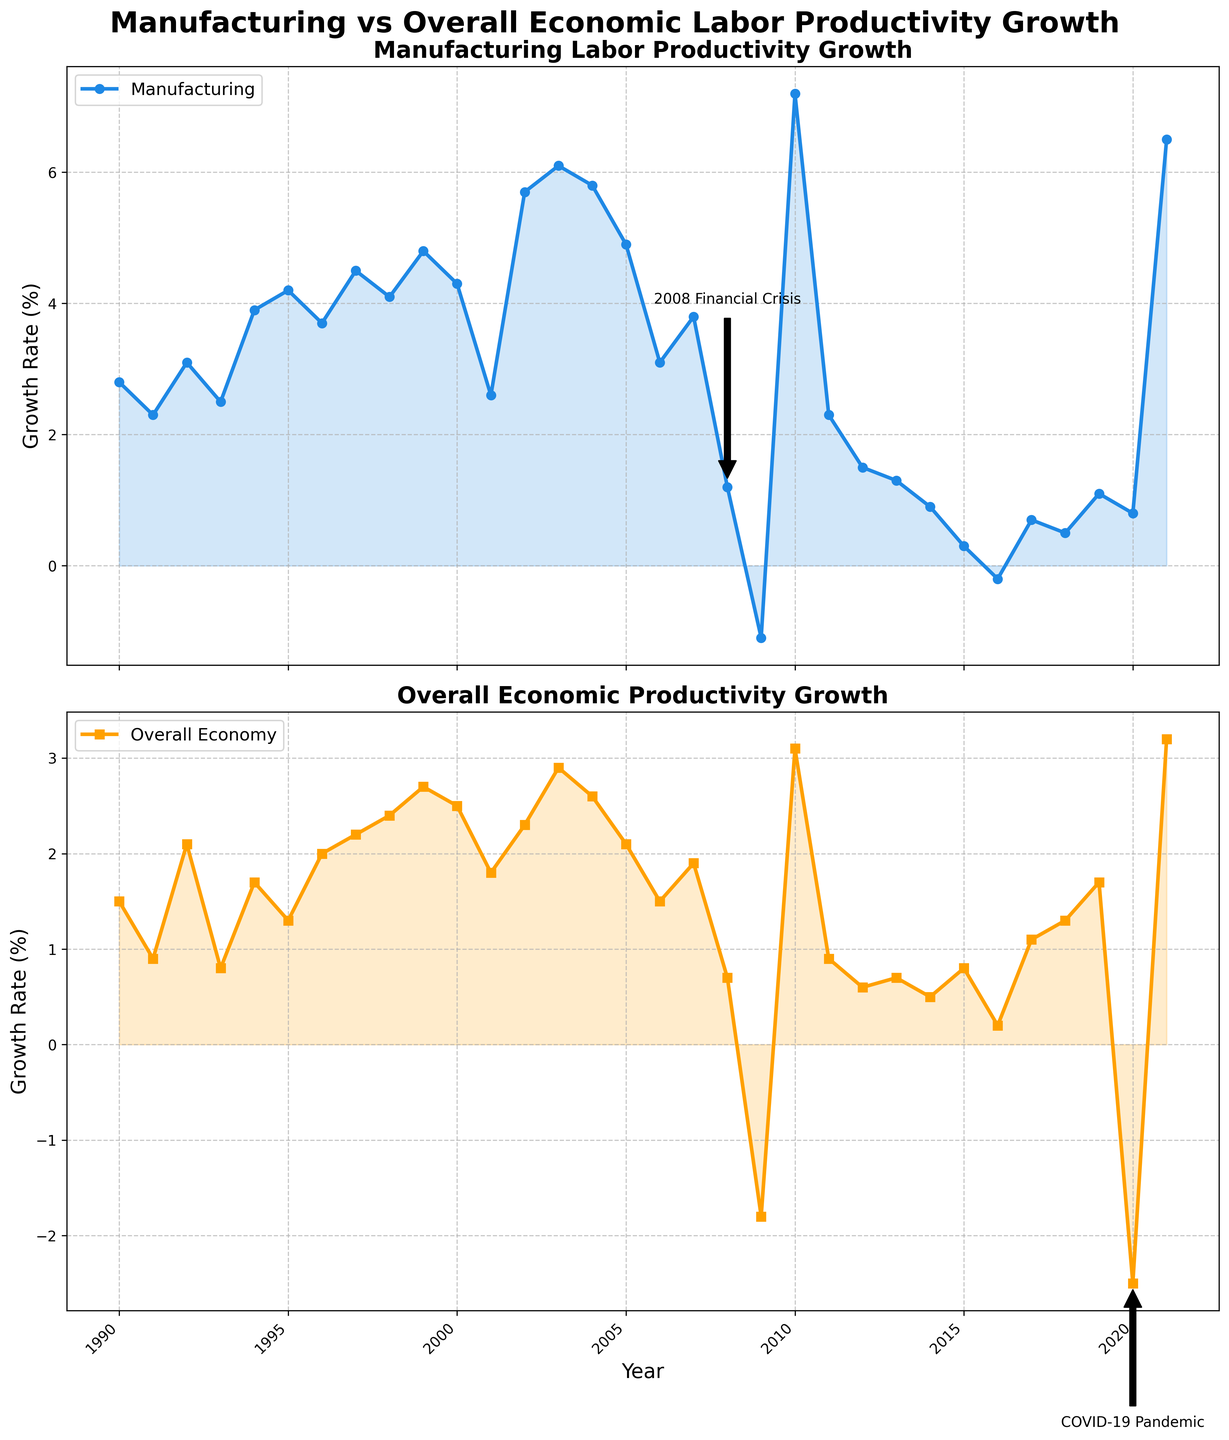Which sector experienced higher productivity growth during 1996? Compare the manufacturing and overall economic productivity growth values for 1996. Manufacturing productivity growth was 3.7% and overall economic productivity growth was 2.0%.
Answer: Manufacturing During which year did manufacturing labor productivity growth peak? Identify the highest point in the manufacturing labor productivity growth line. In 2010, the peak value was 7.2%.
Answer: 2010 What were the growth rates of manufacturing and overall economic productivity during the 2008 financial crisis? Look for the annotations in the figure indicating the 2008 financial crisis. Manufacturing productivity growth was 1.2%, and overall economic productivity growth was 0.7%.
Answer: Manufacturing: 1.2%, Overall: 0.7% How did the manufacturing labor productivity growth rate change from 2009 to 2010? Calculate the difference in manufacturing labor productivity growth rate between 2009 (-1.1%) and 2010 (7.2%). The change is 7.2% - (-1.1%) = 8.3%.
Answer: Increased by 8.3% What is the overall trend of manufacturing labor productivity growth from 1990 to 2021? Observe the direction of the manufacturing labor productivity growth line from 1990 to 2021. It shows ups and downs but generally trends upward until the recent decline post-2010.
Answer: Upward with fluctuations 